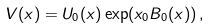Convert formula to latex. <formula><loc_0><loc_0><loc_500><loc_500>V ( x ) = U _ { 0 } ( x ) \exp ( x _ { 0 } B _ { 0 } ( x ) ) \, ,</formula> 